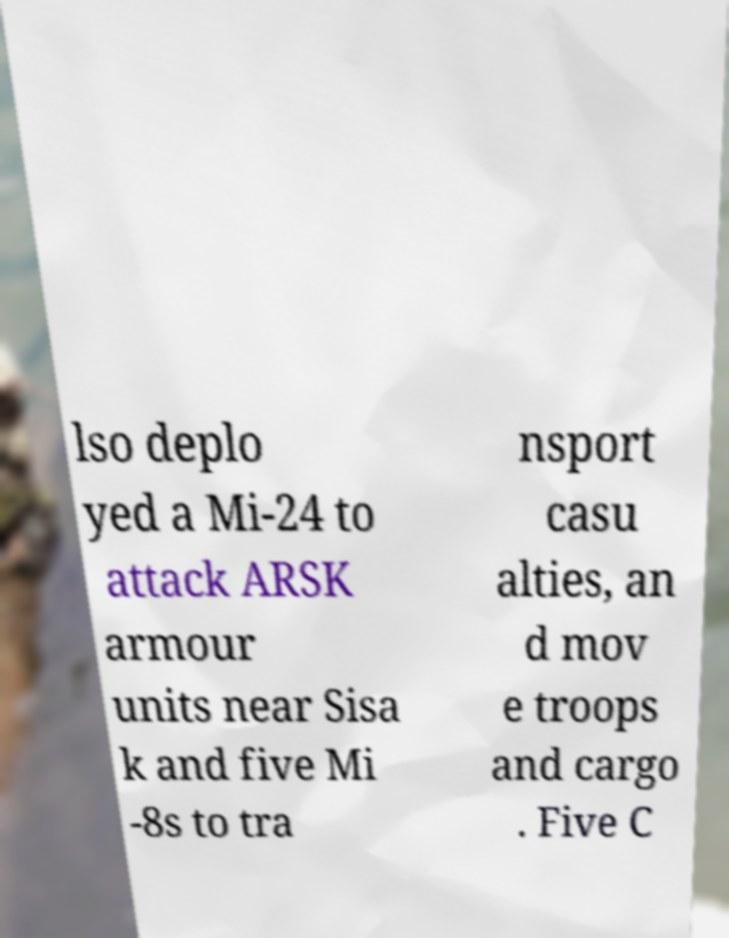Could you assist in decoding the text presented in this image and type it out clearly? lso deplo yed a Mi-24 to attack ARSK armour units near Sisa k and five Mi -8s to tra nsport casu alties, an d mov e troops and cargo . Five C 